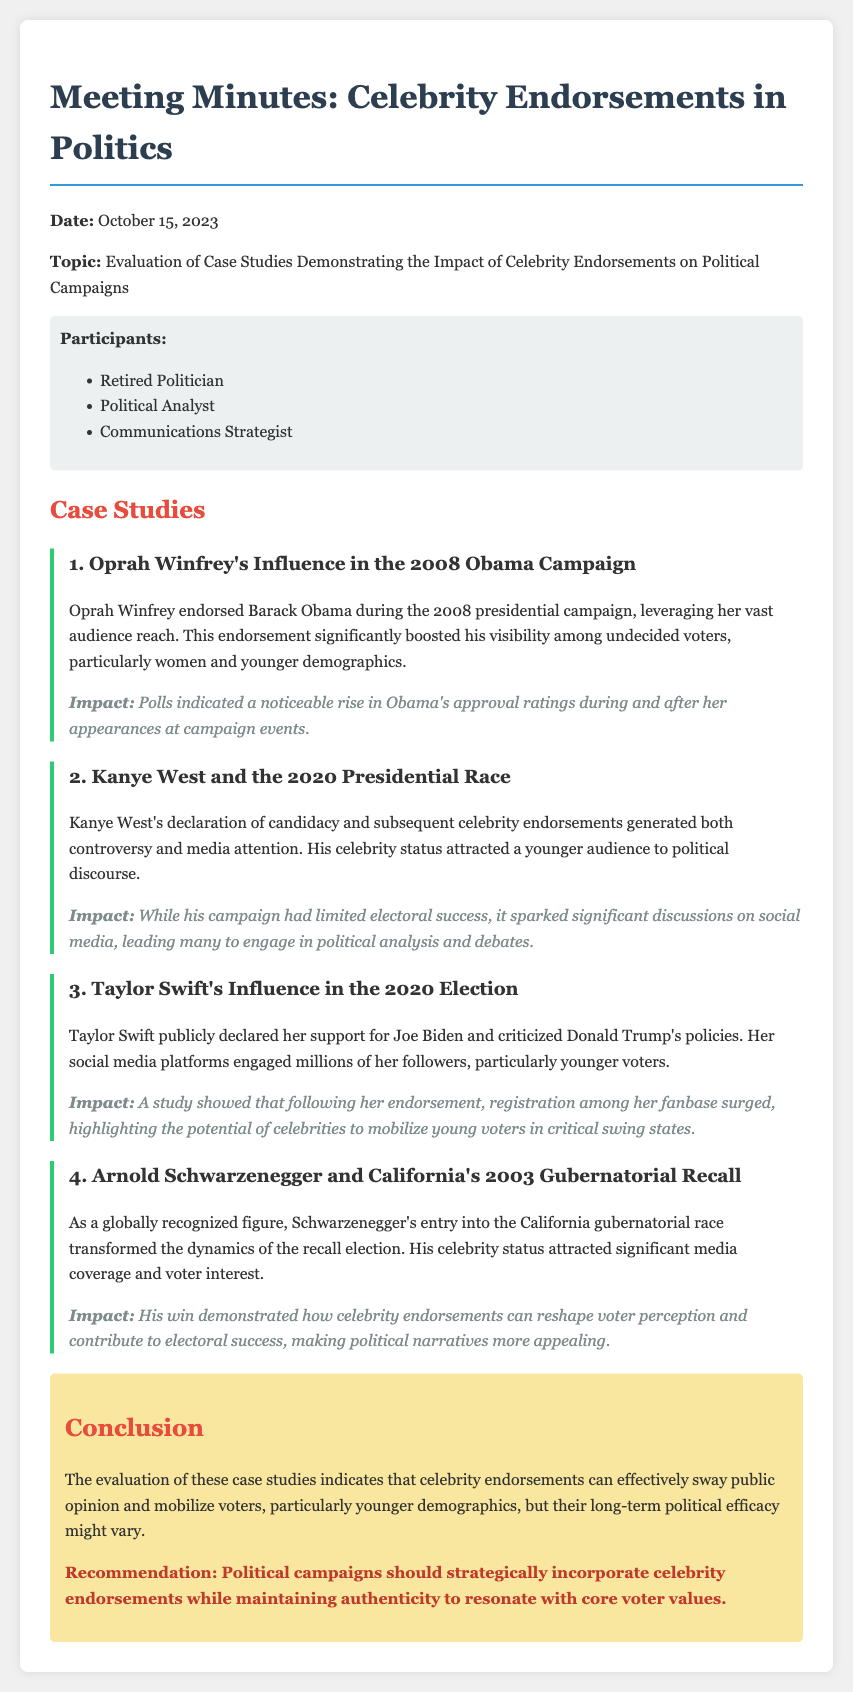What is the date of the meeting? The meeting was held on October 15, 2023.
Answer: October 15, 2023 Who endorsed Barack Obama in 2008? Oprah Winfrey provided her endorsement during the 2008 presidential campaign.
Answer: Oprah Winfrey What demographic showed a noticeable rise in Obama's approval ratings due to Oprah's endorsement? The endorsement significantly boosted visibility among undecided voters, particularly women and younger demographics.
Answer: Women and younger demographics How did Kanye West's campaign impact political discourse? His celebrity status attracted a younger audience to political discourse.
Answer: Younger audience What was the recommendation regarding political campaigns and celebrity endorsements? Political campaigns should strategically incorporate celebrity endorsements while maintaining authenticity.
Answer: Incorporate strategically while maintaining authenticity What was the impact of Taylor Swift's endorsement on voter registration? Following her endorsement, registration among her fanbase surged.
Answer: Registration surged Which case study highlighted significant media coverage and voter interest? Arnold Schwarzenegger's entry into the California gubernatorial race transformed the dynamics of the recall election.
Answer: Arnold Schwarzenegger What common theme was identified in the case studies regarding celebrity endorsements? The evaluation indicates that celebrity endorsements can effectively sway public opinion and mobilize voters.
Answer: Swell public opinion and mobilize voters 